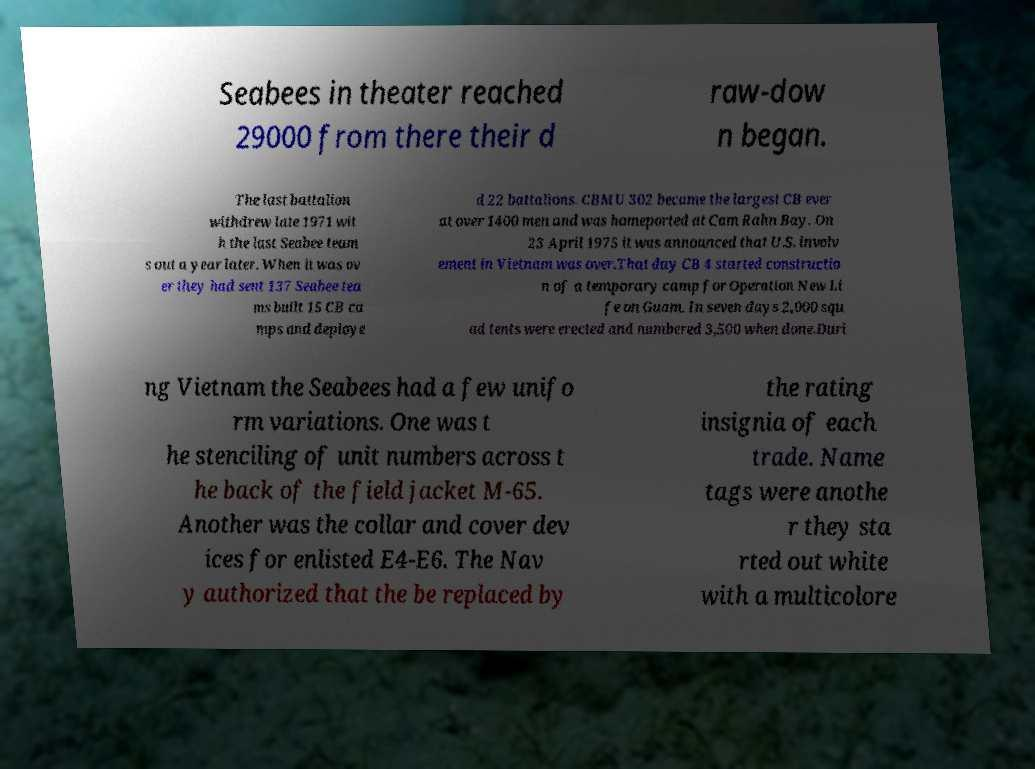Can you read and provide the text displayed in the image?This photo seems to have some interesting text. Can you extract and type it out for me? Seabees in theater reached 29000 from there their d raw-dow n began. The last battalion withdrew late 1971 wit h the last Seabee team s out a year later. When it was ov er they had sent 137 Seabee tea ms built 15 CB ca mps and deploye d 22 battalions. CBMU 302 became the largest CB ever at over 1400 men and was homeported at Cam Rahn Bay. On 23 April 1975 it was announced that U.S. involv ement in Vietnam was over.That day CB 4 started constructio n of a temporary camp for Operation New Li fe on Guam. In seven days 2,000 squ ad tents were erected and numbered 3,500 when done.Duri ng Vietnam the Seabees had a few unifo rm variations. One was t he stenciling of unit numbers across t he back of the field jacket M-65. Another was the collar and cover dev ices for enlisted E4-E6. The Nav y authorized that the be replaced by the rating insignia of each trade. Name tags were anothe r they sta rted out white with a multicolore 